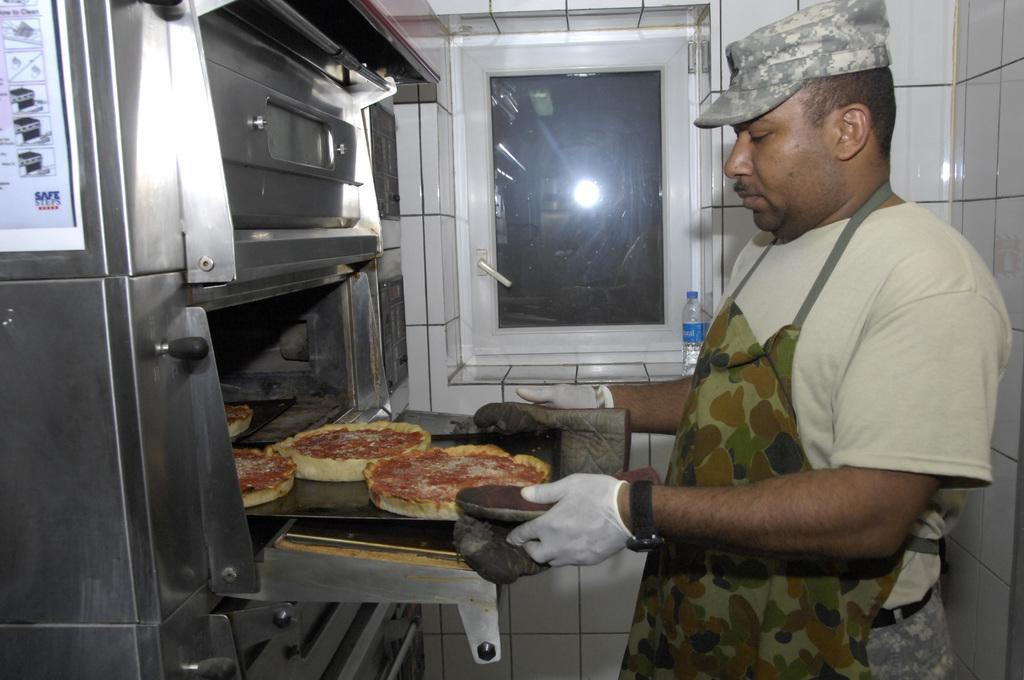<image>
Create a compact narrative representing the image presented. "Safe steps" is written on the left side of the oven. 